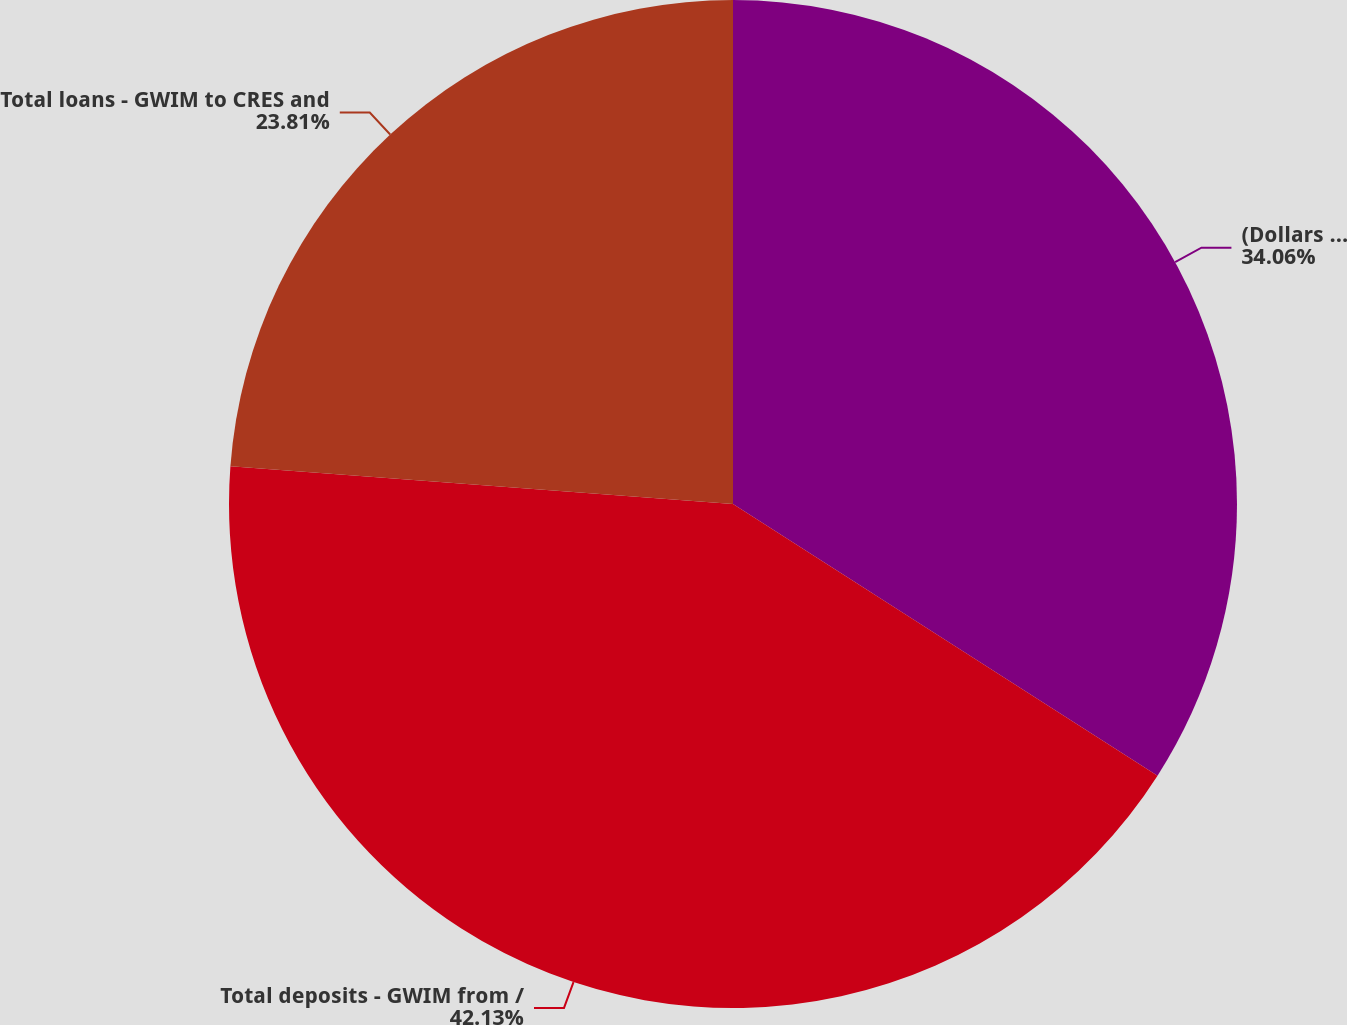Convert chart. <chart><loc_0><loc_0><loc_500><loc_500><pie_chart><fcel>(Dollars in millions)<fcel>Total deposits - GWIM from /<fcel>Total loans - GWIM to CRES and<nl><fcel>34.06%<fcel>42.13%<fcel>23.81%<nl></chart> 